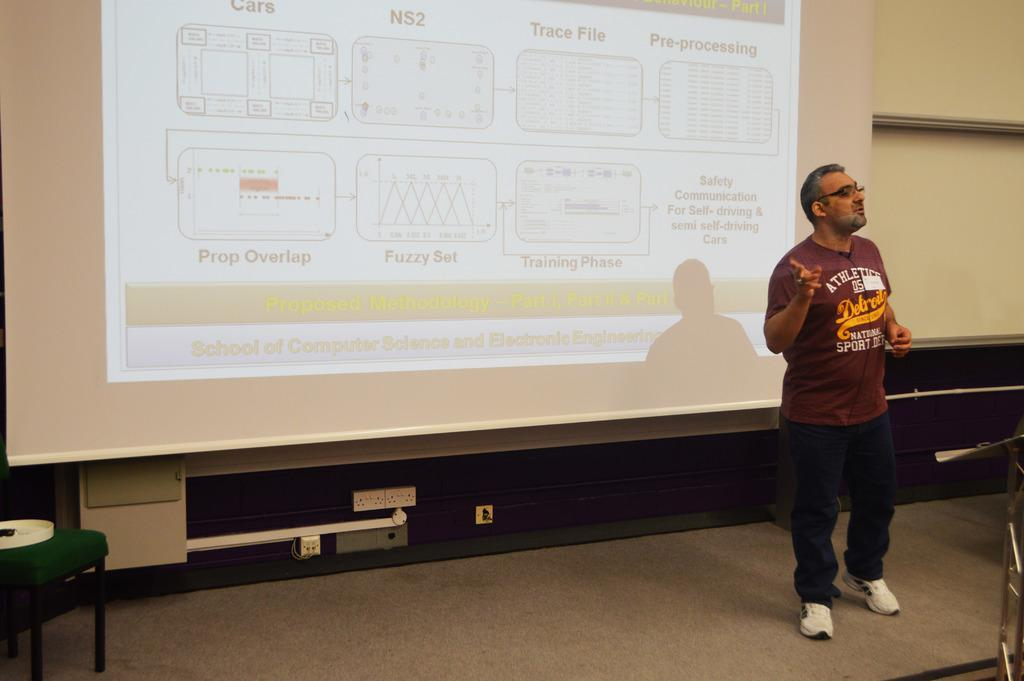<image>
Render a clear and concise summary of the photo. A man doing a presentation on computer science and electronic engineering. 